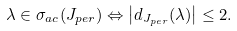Convert formula to latex. <formula><loc_0><loc_0><loc_500><loc_500>\lambda \in \sigma _ { a c } ( J _ { p e r } ) \Leftrightarrow \left | d _ { J _ { p e r } } ( \lambda ) \right | \leq 2 .</formula> 